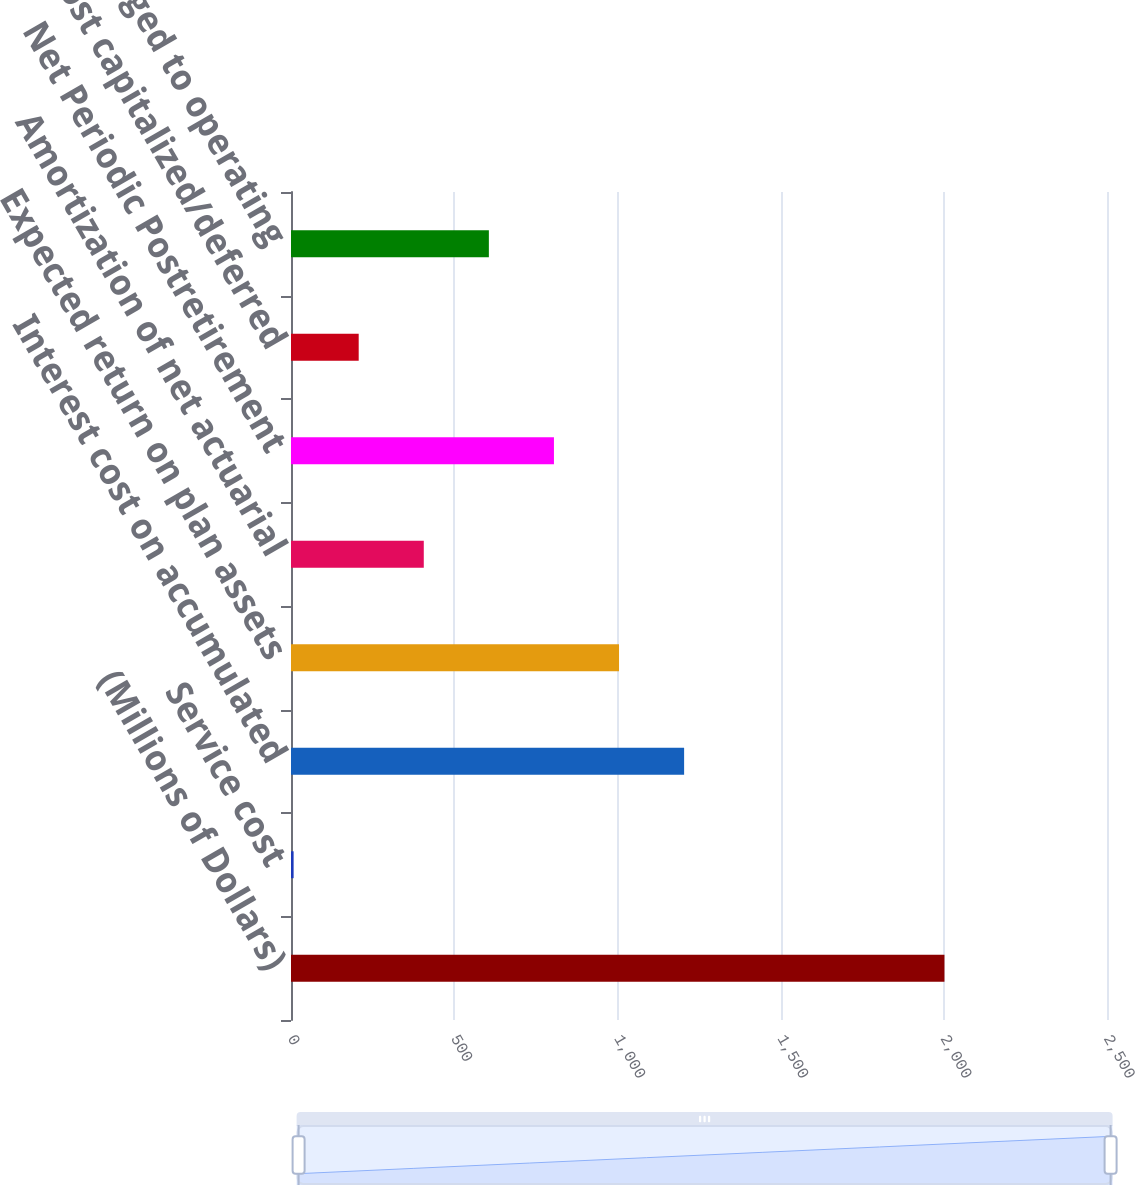Convert chart to OTSL. <chart><loc_0><loc_0><loc_500><loc_500><bar_chart><fcel>(Millions of Dollars)<fcel>Service cost<fcel>Interest cost on accumulated<fcel>Expected return on plan assets<fcel>Amortization of net actuarial<fcel>Net Periodic Postretirement<fcel>Cost capitalized/deferred<fcel>Cost charged to operating<nl><fcel>2002<fcel>8<fcel>1204.4<fcel>1005<fcel>406.8<fcel>805.6<fcel>207.4<fcel>606.2<nl></chart> 